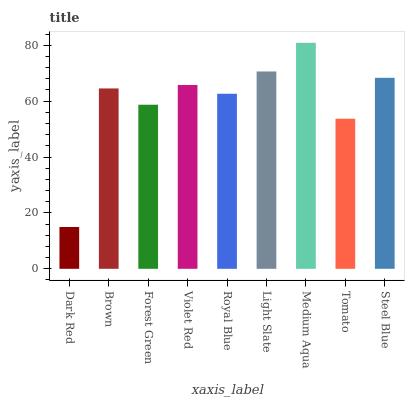Is Brown the minimum?
Answer yes or no. No. Is Brown the maximum?
Answer yes or no. No. Is Brown greater than Dark Red?
Answer yes or no. Yes. Is Dark Red less than Brown?
Answer yes or no. Yes. Is Dark Red greater than Brown?
Answer yes or no. No. Is Brown less than Dark Red?
Answer yes or no. No. Is Brown the high median?
Answer yes or no. Yes. Is Brown the low median?
Answer yes or no. Yes. Is Violet Red the high median?
Answer yes or no. No. Is Light Slate the low median?
Answer yes or no. No. 